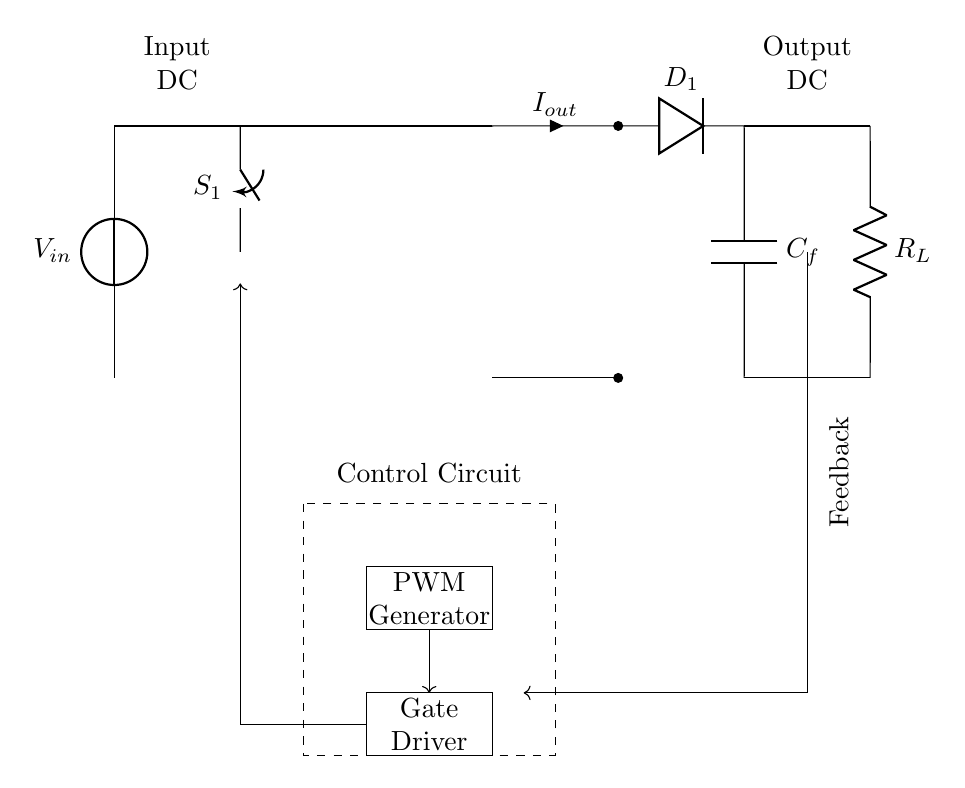What type of switch is used in this circuit? The circuit includes a closing switch labeled as "S1." This type of switch typically allows current to flow when closed.
Answer: closing switch What component regulates the gate of the high-frequency switch? The circuit shows a gate driver component connected to the switch. The gate driver is responsible for providing the suitable input signal to control the switch operation.
Answer: Gate Driver What is the purpose of the PWM generator in this circuit? The PWM generator produces pulse width modulation signals needed to control the switching behavior of the high-frequency switch, allowing for variable output voltage.
Answer: to control switch operation What is the role of the transformer in this circuit? The transformer serves to isolate the input and output sides of the circuit while stepping up or down the voltage level according to the design needs.
Answer: voltage isolation and transformation How is feedback implemented in this circuit? Feedback is indicated by a connecting line that returns from the output to the control circuit, allowing for regulation and correction of the output based on the desired performance.
Answer: through a feedback loop What component converts the AC output from the transformer to DC? The circuit diagram has a diode labeled "D1," which functions as a rectifier, converting the alternating current produced by the transformer into direct current for the output.
Answer: Diode D1 What is the function of the filter capacitor in this system? The filter capacitor, represented as "C_f," smooths out the rectified output by minimizing voltage ripples, resulting in a more stable DC output to the load.
Answer: to smooth DC output 